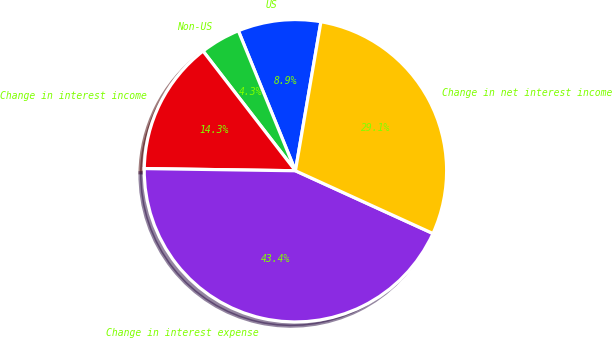Convert chart. <chart><loc_0><loc_0><loc_500><loc_500><pie_chart><fcel>US<fcel>Non-US<fcel>Change in interest income<fcel>Change in interest expense<fcel>Change in net interest income<nl><fcel>8.86%<fcel>4.3%<fcel>14.31%<fcel>43.42%<fcel>29.12%<nl></chart> 